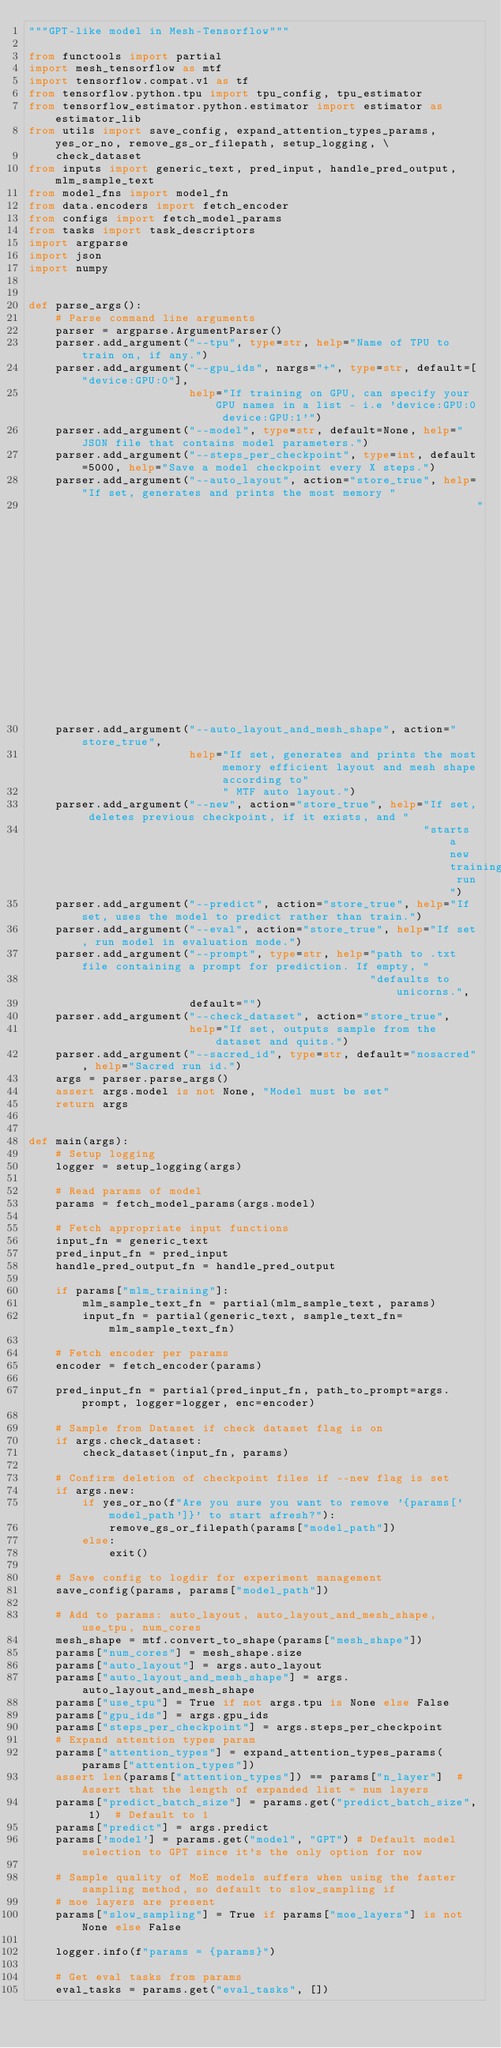<code> <loc_0><loc_0><loc_500><loc_500><_Python_>"""GPT-like model in Mesh-Tensorflow"""

from functools import partial
import mesh_tensorflow as mtf
import tensorflow.compat.v1 as tf
from tensorflow.python.tpu import tpu_config, tpu_estimator
from tensorflow_estimator.python.estimator import estimator as estimator_lib
from utils import save_config, expand_attention_types_params, yes_or_no, remove_gs_or_filepath, setup_logging, \
    check_dataset
from inputs import generic_text, pred_input, handle_pred_output, mlm_sample_text
from model_fns import model_fn
from data.encoders import fetch_encoder
from configs import fetch_model_params
from tasks import task_descriptors
import argparse
import json
import numpy


def parse_args():
    # Parse command line arguments
    parser = argparse.ArgumentParser()
    parser.add_argument("--tpu", type=str, help="Name of TPU to train on, if any.")
    parser.add_argument("--gpu_ids", nargs="+", type=str, default=["device:GPU:0"],
                        help="If training on GPU, can specify your GPU names in a list - i.e 'device:GPU:0 device:GPU:1'")
    parser.add_argument("--model", type=str, default=None, help="JSON file that contains model parameters.")
    parser.add_argument("--steps_per_checkpoint", type=int, default=5000, help="Save a model checkpoint every X steps.")
    parser.add_argument("--auto_layout", action="store_true", help="If set, generates and prints the most memory "
                                                                   "efficient layout according to MTF auto layout.")
    parser.add_argument("--auto_layout_and_mesh_shape", action="store_true",
                        help="If set, generates and prints the most memory efficient layout and mesh shape according to"
                             " MTF auto layout.")
    parser.add_argument("--new", action="store_true", help="If set, deletes previous checkpoint, if it exists, and "
                                                           "starts a new training run")
    parser.add_argument("--predict", action="store_true", help="If set, uses the model to predict rather than train.")
    parser.add_argument("--eval", action="store_true", help="If set, run model in evaluation mode.")
    parser.add_argument("--prompt", type=str, help="path to .txt file containing a prompt for prediction. If empty, "
                                                   "defaults to unicorns.",
                        default="")
    parser.add_argument("--check_dataset", action="store_true",
                        help="If set, outputs sample from the dataset and quits.")
    parser.add_argument("--sacred_id", type=str, default="nosacred", help="Sacred run id.")
    args = parser.parse_args()
    assert args.model is not None, "Model must be set"
    return args


def main(args):
    # Setup logging
    logger = setup_logging(args)

    # Read params of model
    params = fetch_model_params(args.model)

    # Fetch appropriate input functions
    input_fn = generic_text
    pred_input_fn = pred_input
    handle_pred_output_fn = handle_pred_output

    if params["mlm_training"]:
        mlm_sample_text_fn = partial(mlm_sample_text, params)
        input_fn = partial(generic_text, sample_text_fn=mlm_sample_text_fn)

    # Fetch encoder per params
    encoder = fetch_encoder(params)

    pred_input_fn = partial(pred_input_fn, path_to_prompt=args.prompt, logger=logger, enc=encoder)

    # Sample from Dataset if check dataset flag is on
    if args.check_dataset:
        check_dataset(input_fn, params)

    # Confirm deletion of checkpoint files if --new flag is set
    if args.new:
        if yes_or_no(f"Are you sure you want to remove '{params['model_path']}' to start afresh?"):
            remove_gs_or_filepath(params["model_path"])
        else:
            exit()

    # Save config to logdir for experiment management
    save_config(params, params["model_path"])

    # Add to params: auto_layout, auto_layout_and_mesh_shape, use_tpu, num_cores
    mesh_shape = mtf.convert_to_shape(params["mesh_shape"])
    params["num_cores"] = mesh_shape.size
    params["auto_layout"] = args.auto_layout
    params["auto_layout_and_mesh_shape"] = args.auto_layout_and_mesh_shape
    params["use_tpu"] = True if not args.tpu is None else False
    params["gpu_ids"] = args.gpu_ids
    params["steps_per_checkpoint"] = args.steps_per_checkpoint
    # Expand attention types param
    params["attention_types"] = expand_attention_types_params(params["attention_types"])
    assert len(params["attention_types"]) == params["n_layer"]  # Assert that the length of expanded list = num layers
    params["predict_batch_size"] = params.get("predict_batch_size", 1)  # Default to 1
    params["predict"] = args.predict
    params['model'] = params.get("model", "GPT") # Default model selection to GPT since it's the only option for now

    # Sample quality of MoE models suffers when using the faster sampling method, so default to slow_sampling if
    # moe layers are present
    params["slow_sampling"] = True if params["moe_layers"] is not None else False

    logger.info(f"params = {params}")

    # Get eval tasks from params
    eval_tasks = params.get("eval_tasks", [])</code> 